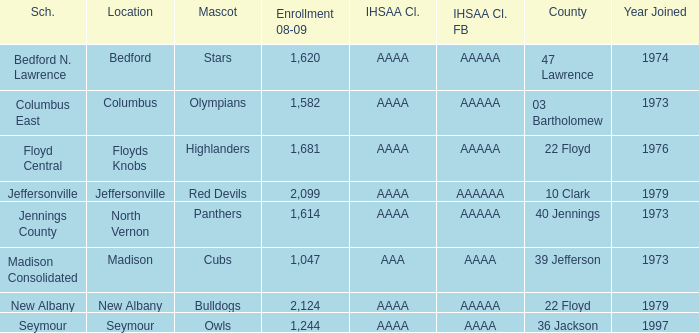What school is in 36 Jackson? Seymour. 